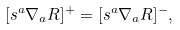Convert formula to latex. <formula><loc_0><loc_0><loc_500><loc_500>[ s ^ { a } \nabla _ { a } R ] ^ { + } = [ s ^ { a } \nabla _ { a } R ] ^ { - } ,</formula> 